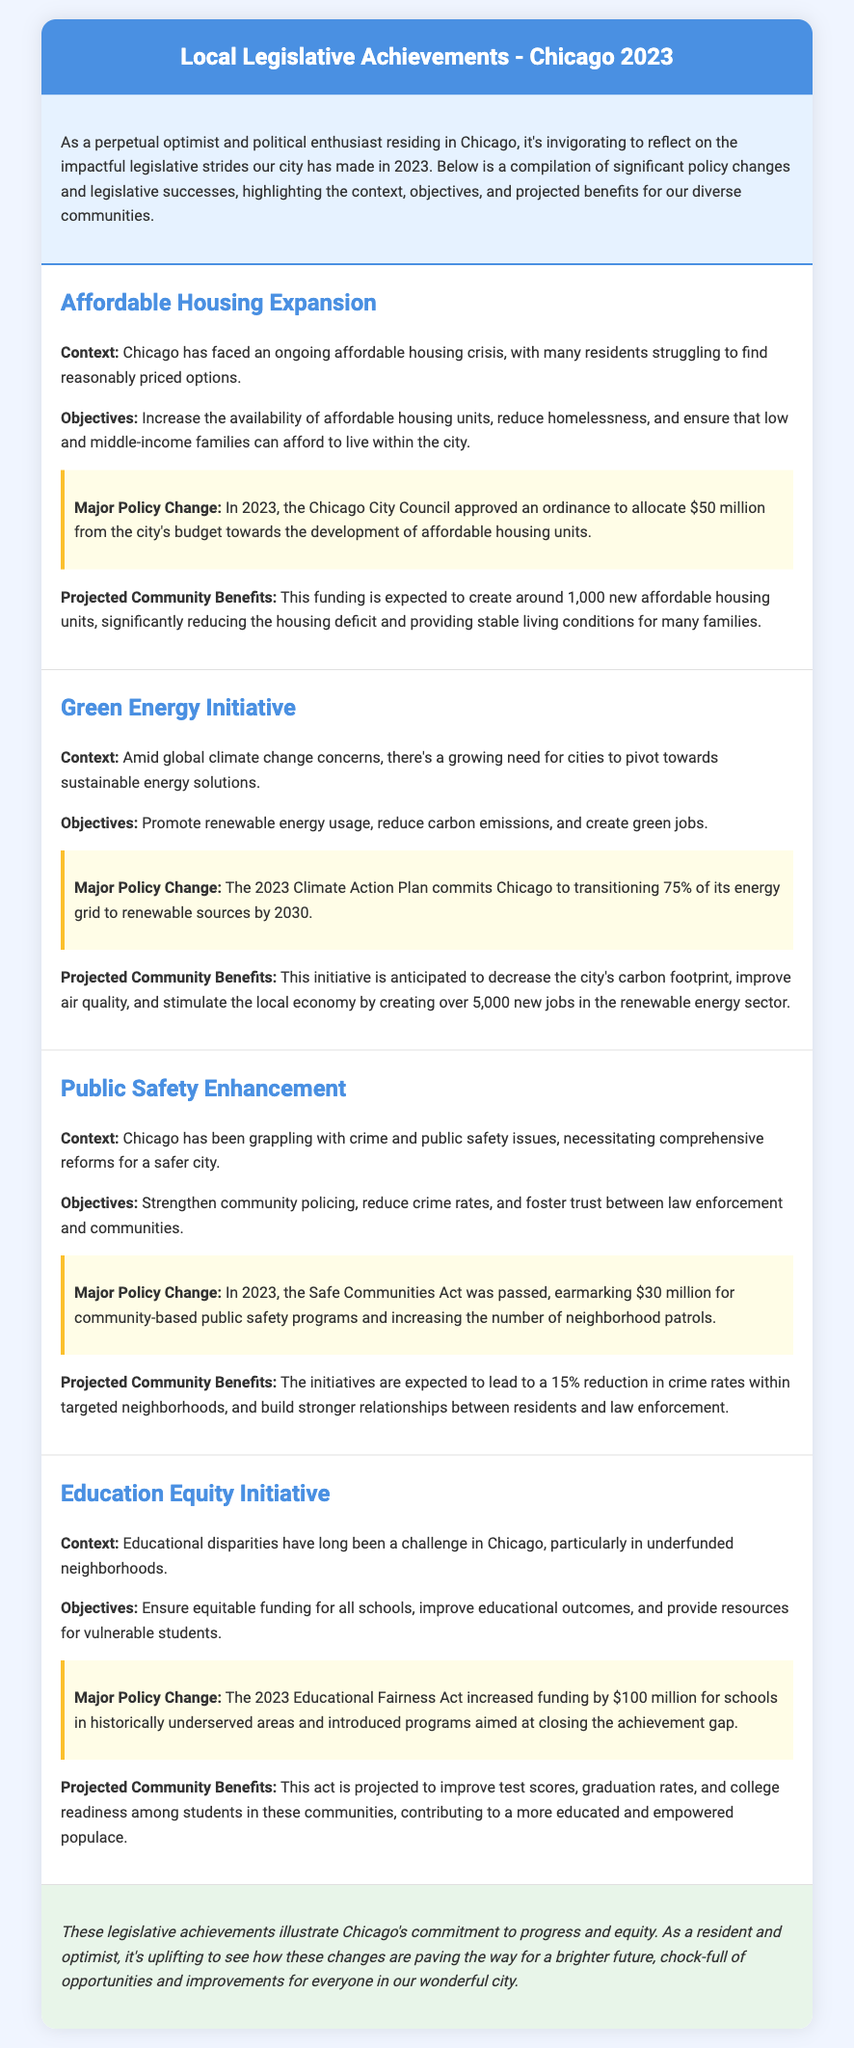What is the budget allocation for affordable housing? The document states that $50 million was allocated from the city's budget towards the development of affordable housing units.
Answer: $50 million How many new affordable housing units are projected to be created? The document mentions that the funding is expected to create around 1,000 new affordable housing units.
Answer: 1,000 What percentage of the energy grid is Chicago transitioning to renewable sources by 2030? The document indicates that Chicago commits to transitioning 75% of its energy grid to renewable sources.
Answer: 75% What is the funding amount earmarked for community-based public safety programs? The Safe Communities Act earmarked $30 million for community-based public safety programs.
Answer: $30 million What is the increase in funding for schools in historically underserved areas? According to the document, the increase in funding is $100 million for schools in historically underserved areas.
Answer: $100 million What is the expected reduction in crime rates within targeted neighborhoods? The document states that initiatives are expected to lead to a 15% reduction in crime rates within targeted neighborhoods.
Answer: 15% Which act aims to close the achievement gap in education? The Educational Fairness Act is the act mentioned that aims to close the achievement gap in education.
Answer: Educational Fairness Act How many jobs are anticipated to be created in the renewable energy sector? The document anticipates that over 5,000 new jobs will be created in the renewable energy sector.
Answer: 5,000 What is the main objective of the Education Equity Initiative? The main objective is to ensure equitable funding for all schools and improve educational outcomes.
Answer: Ensure equitable funding and improve educational outcomes 